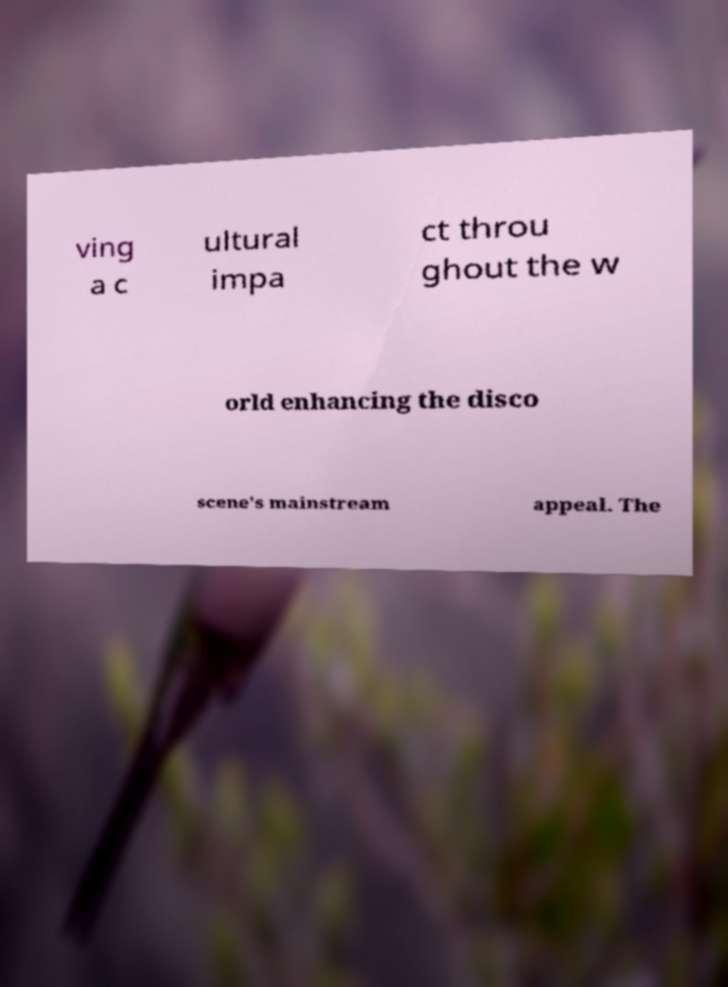Please identify and transcribe the text found in this image. ving a c ultural impa ct throu ghout the w orld enhancing the disco scene's mainstream appeal. The 